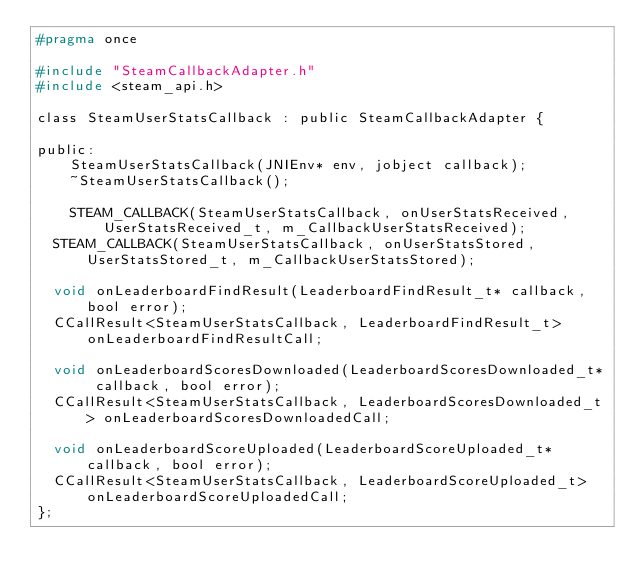<code> <loc_0><loc_0><loc_500><loc_500><_C_>#pragma once

#include "SteamCallbackAdapter.h"
#include <steam_api.h>

class SteamUserStatsCallback : public SteamCallbackAdapter {

public:
    SteamUserStatsCallback(JNIEnv* env, jobject callback);
    ~SteamUserStatsCallback();

    STEAM_CALLBACK(SteamUserStatsCallback, onUserStatsReceived, UserStatsReceived_t, m_CallbackUserStatsReceived);
	STEAM_CALLBACK(SteamUserStatsCallback, onUserStatsStored, UserStatsStored_t, m_CallbackUserStatsStored);

	void onLeaderboardFindResult(LeaderboardFindResult_t* callback, bool error);
	CCallResult<SteamUserStatsCallback, LeaderboardFindResult_t> onLeaderboardFindResultCall;

	void onLeaderboardScoresDownloaded(LeaderboardScoresDownloaded_t* callback, bool error);
	CCallResult<SteamUserStatsCallback, LeaderboardScoresDownloaded_t> onLeaderboardScoresDownloadedCall;

	void onLeaderboardScoreUploaded(LeaderboardScoreUploaded_t* callback, bool error);
	CCallResult<SteamUserStatsCallback, LeaderboardScoreUploaded_t> onLeaderboardScoreUploadedCall;
};
</code> 